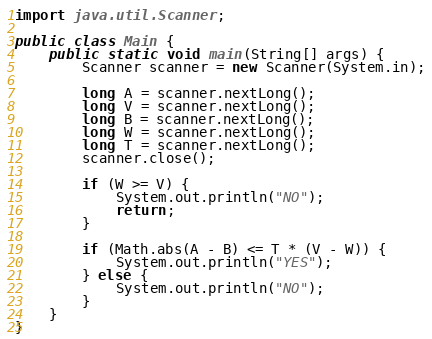<code> <loc_0><loc_0><loc_500><loc_500><_Java_>import java.util.Scanner;

public class Main {
    public static void main(String[] args) {
        Scanner scanner = new Scanner(System.in);

        long A = scanner.nextLong();
        long V = scanner.nextLong();
        long B = scanner.nextLong();
        long W = scanner.nextLong();
        long T = scanner.nextLong();
        scanner.close();

        if (W >= V) {
            System.out.println("NO");
            return;
        }

        if (Math.abs(A - B) <= T * (V - W)) {
            System.out.println("YES");
        } else {
            System.out.println("NO");
        }
    }
}
</code> 